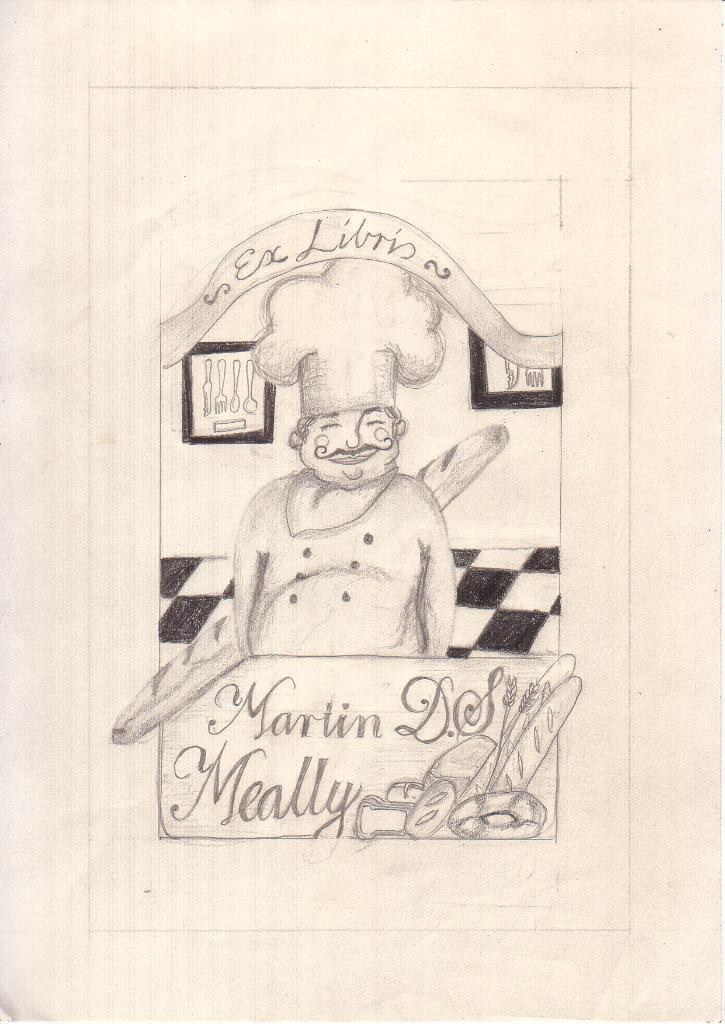What is depicted on the white paper in the image? There is a drawing of a person and writing on the white paper in the image. Can you describe the drawing in more detail? The drawing is of a person, but no specific details about the person's appearance are provided. What is the nature of the writing on the white paper? The nature of the writing is not specified in the facts provided. How many bananas are being served by the person in the drawing? There is no mention of bananas or a person serving them in the image. What type of face does the person in the drawing have? The facts provided do not give any specific details about the person's appearance, including their face. 